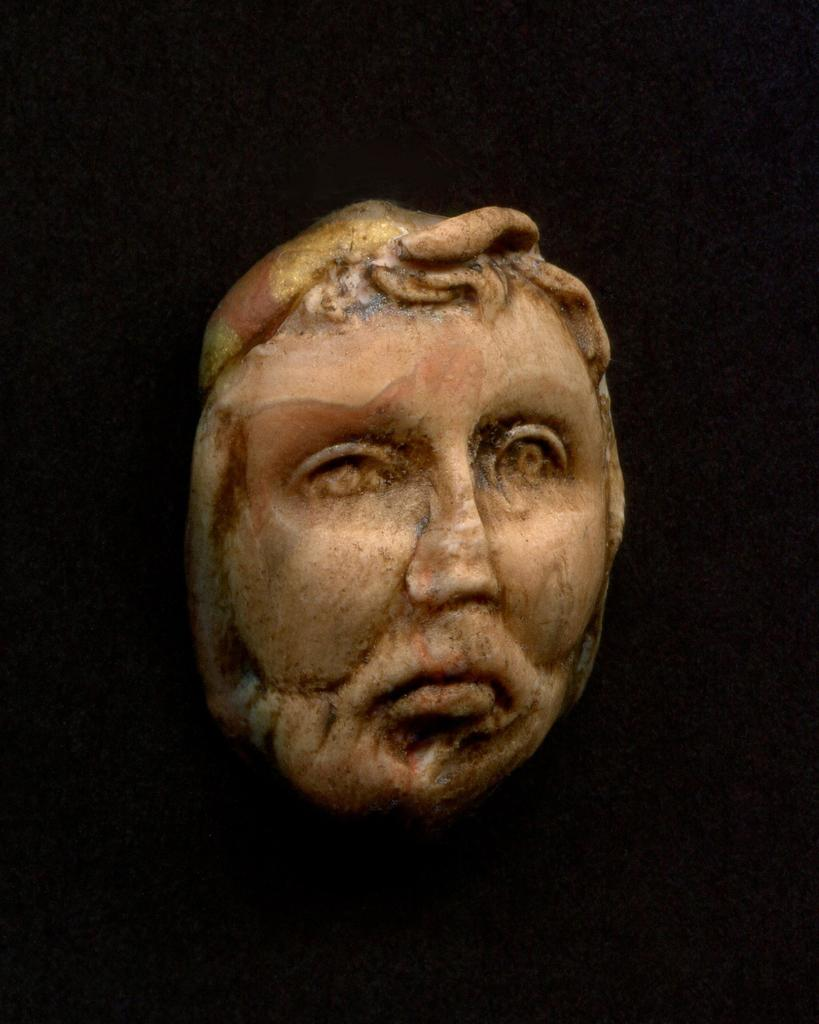What is the main subject of the picture? The main subject of the picture is a sculpture of a face. What can be observed about the background of the image? The background of the image is dark. What month is depicted in the sculpture of the face? The sculpture of the face does not depict a month; it is a sculpture of a face. What scientific discovery is represented by the sculpture of the face? The sculpture of the face does not represent any scientific discovery; it is a sculpture of a face. 